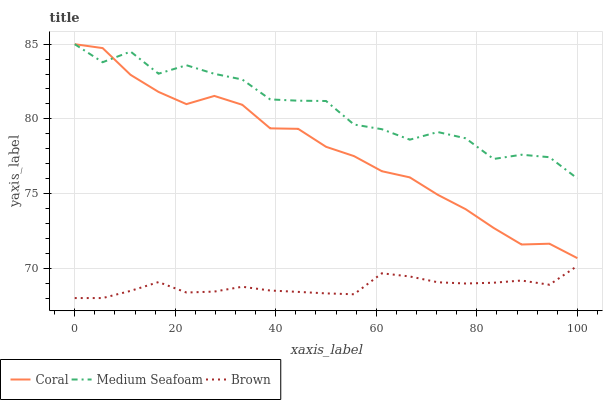Does Brown have the minimum area under the curve?
Answer yes or no. Yes. Does Medium Seafoam have the maximum area under the curve?
Answer yes or no. Yes. Does Coral have the minimum area under the curve?
Answer yes or no. No. Does Coral have the maximum area under the curve?
Answer yes or no. No. Is Brown the smoothest?
Answer yes or no. Yes. Is Medium Seafoam the roughest?
Answer yes or no. Yes. Is Coral the smoothest?
Answer yes or no. No. Is Coral the roughest?
Answer yes or no. No. Does Brown have the lowest value?
Answer yes or no. Yes. Does Coral have the lowest value?
Answer yes or no. No. Does Medium Seafoam have the highest value?
Answer yes or no. Yes. Is Brown less than Medium Seafoam?
Answer yes or no. Yes. Is Coral greater than Brown?
Answer yes or no. Yes. Does Coral intersect Medium Seafoam?
Answer yes or no. Yes. Is Coral less than Medium Seafoam?
Answer yes or no. No. Is Coral greater than Medium Seafoam?
Answer yes or no. No. Does Brown intersect Medium Seafoam?
Answer yes or no. No. 